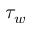<formula> <loc_0><loc_0><loc_500><loc_500>\tau _ { w }</formula> 